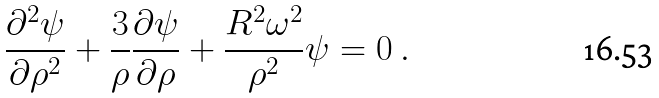Convert formula to latex. <formula><loc_0><loc_0><loc_500><loc_500>\frac { \partial ^ { 2 } \psi } { \partial \rho ^ { 2 } } + \frac { 3 } { \rho } \frac { \partial \psi } { \partial \rho } + \frac { R ^ { 2 } \omega ^ { 2 } } { \rho ^ { 2 } } \psi = 0 \ .</formula> 